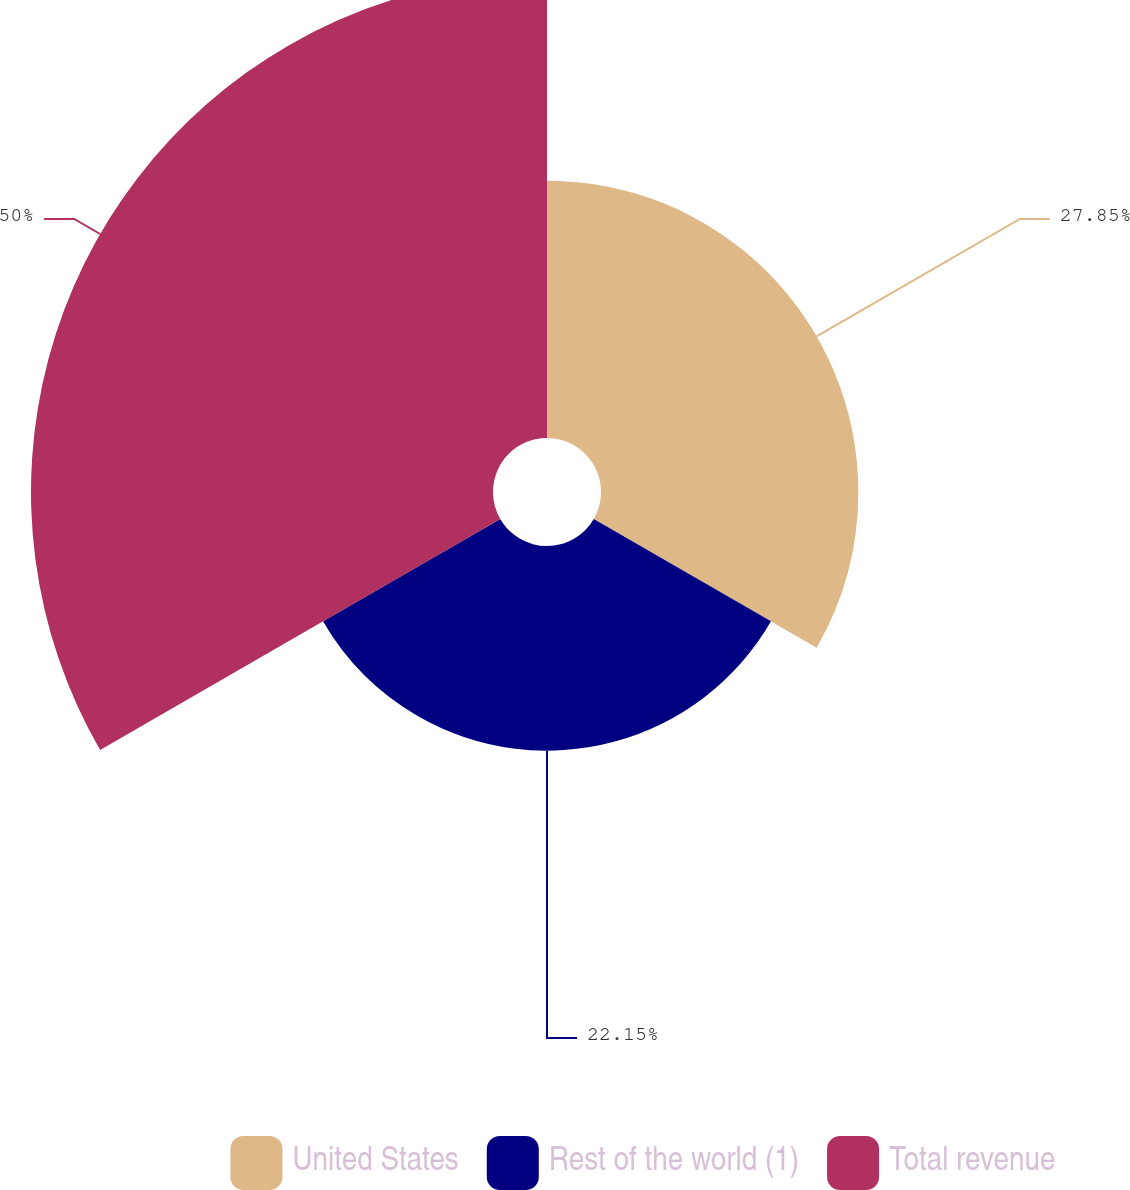Convert chart. <chart><loc_0><loc_0><loc_500><loc_500><pie_chart><fcel>United States<fcel>Rest of the world (1)<fcel>Total revenue<nl><fcel>27.85%<fcel>22.15%<fcel>50.0%<nl></chart> 